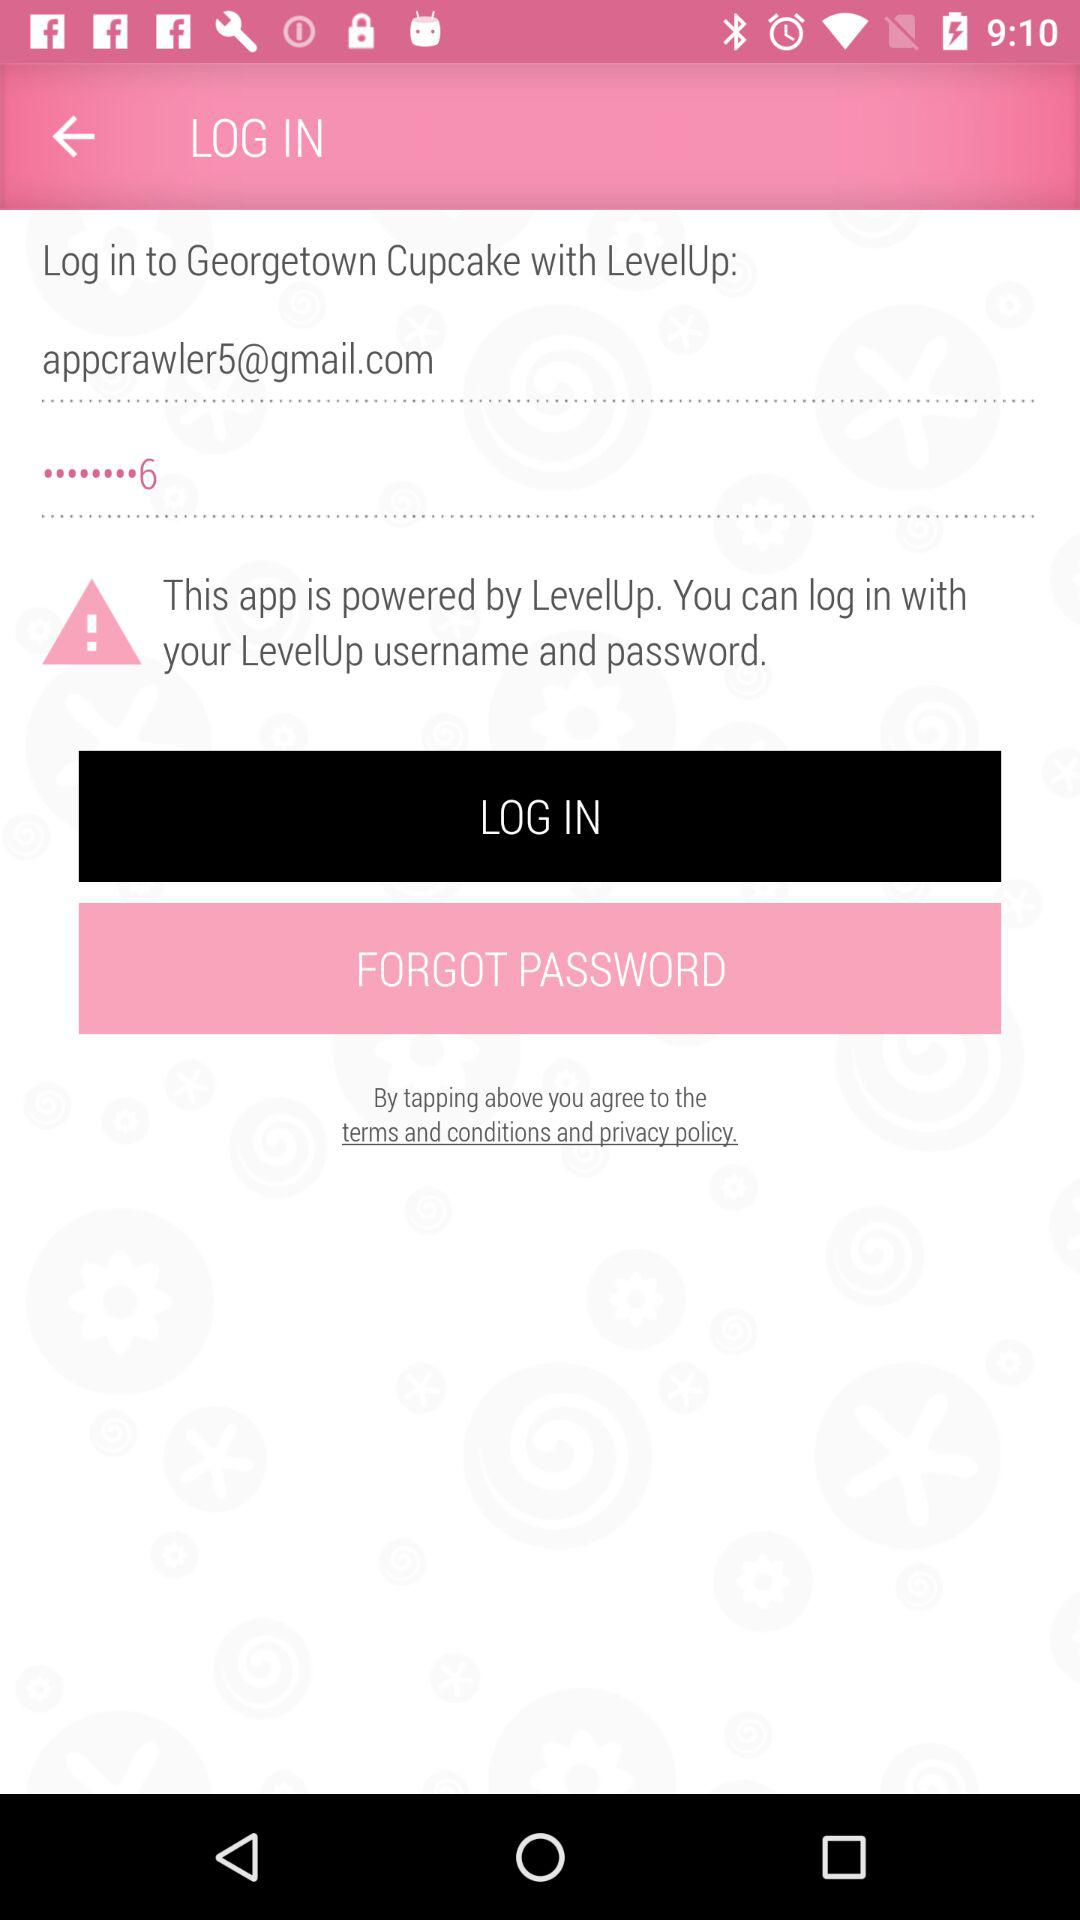What is the email address? The email address is appcrawler5@gmail.com. 